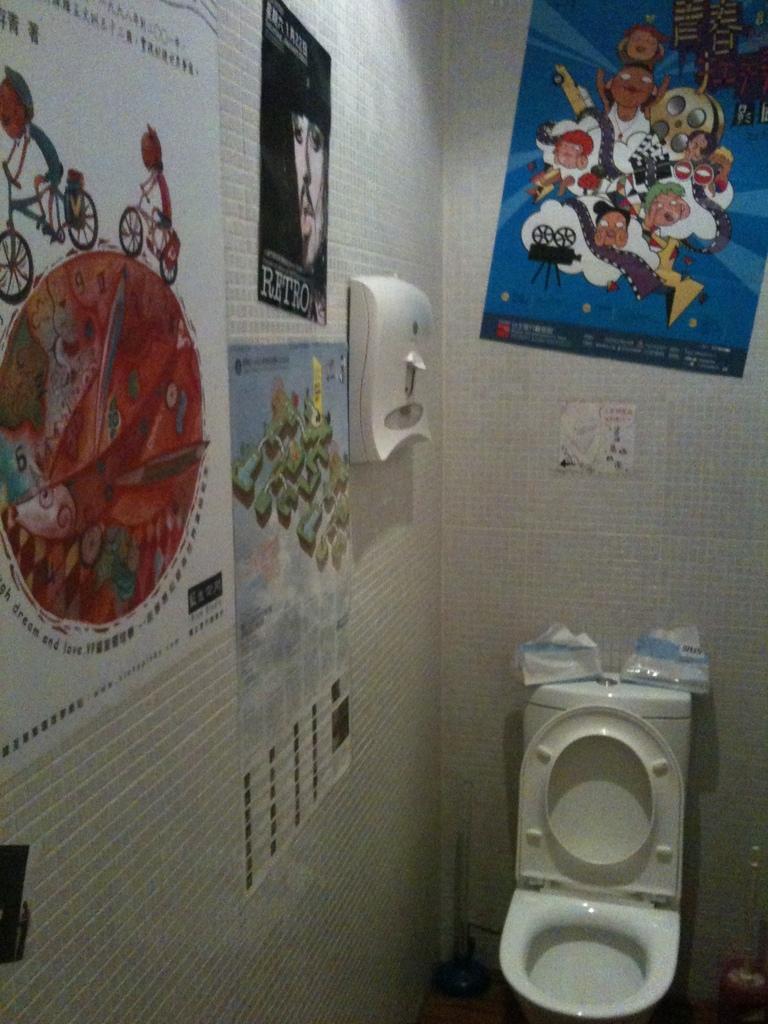In one or two sentences, can you explain what this image depicts? At the bottom there is a wash basin. On the left there are posters attached to the wall. In the background there is a poster on the wall. 